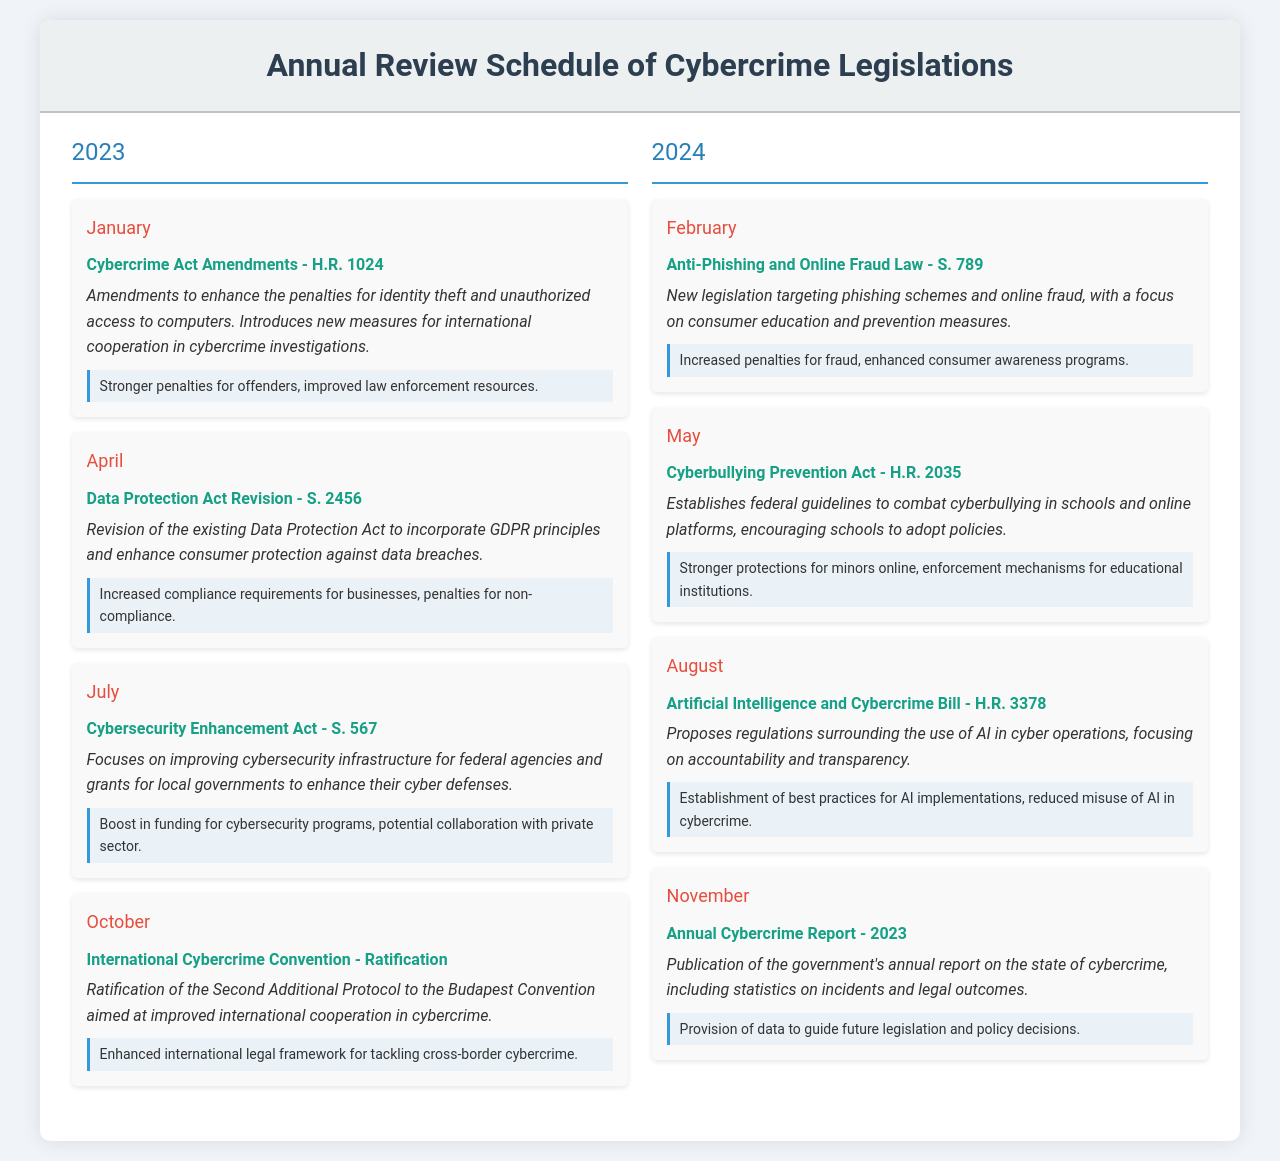What is the title of the amendment in January 2023? The document states that the title of the amendment is "Cybercrime Act Amendments - H.R. 1024."
Answer: Cybercrime Act Amendments - H.R. 1024 What is introduced in April 2023? The document mentions that in April 2023, the "Data Protection Act Revision - S. 2456" is introduced.
Answer: Data Protection Act Revision - S. 2456 What month does the International Cybercrime Convention get ratified? According to the document, the ratification occurs in October.
Answer: October What is the focus of the legislation introduced in February 2024? The focus is specified in the document as targeting phishing schemes and online fraud.
Answer: Targeting phishing schemes and online fraud How many key updates are there listed for the year 2023? The document lists four key updates for the year 2023.
Answer: Four What is the impact of the Cybersecurity Enhancement Act? The document notes that the impact is a boost in funding for cybersecurity programs.
Answer: Boost in funding for cybersecurity programs Which act aims to combat cyberbullying in schools? The document states that the "Cyberbullying Prevention Act - H.R. 2035" aims to combat cyberbullying.
Answer: Cyberbullying Prevention Act - H.R. 2035 What type of report is published in November 2024? The document indicates that an Annual Cybercrime Report is published.
Answer: Annual Cybercrime Report How frequently is the Annual Review Schedule of Cybercrime Legislations updated? The document implies an annual basis is used for the update schedule.
Answer: Annually 